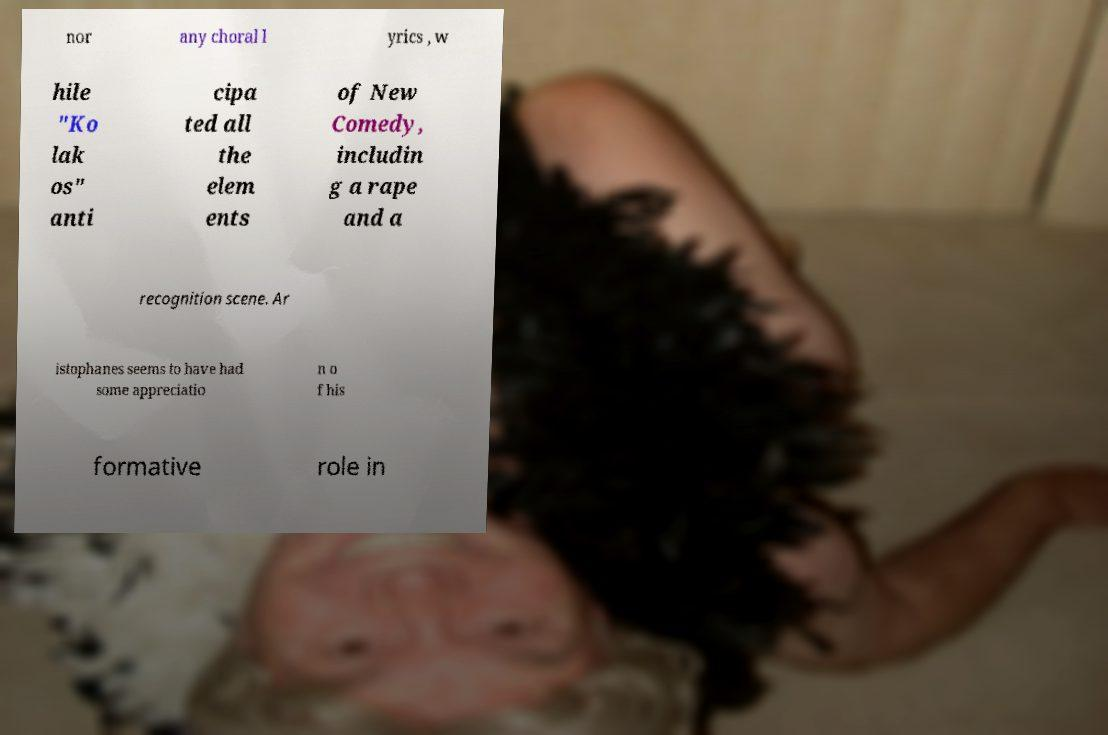I need the written content from this picture converted into text. Can you do that? nor any choral l yrics , w hile "Ko lak os" anti cipa ted all the elem ents of New Comedy, includin g a rape and a recognition scene. Ar istophanes seems to have had some appreciatio n o f his formative role in 